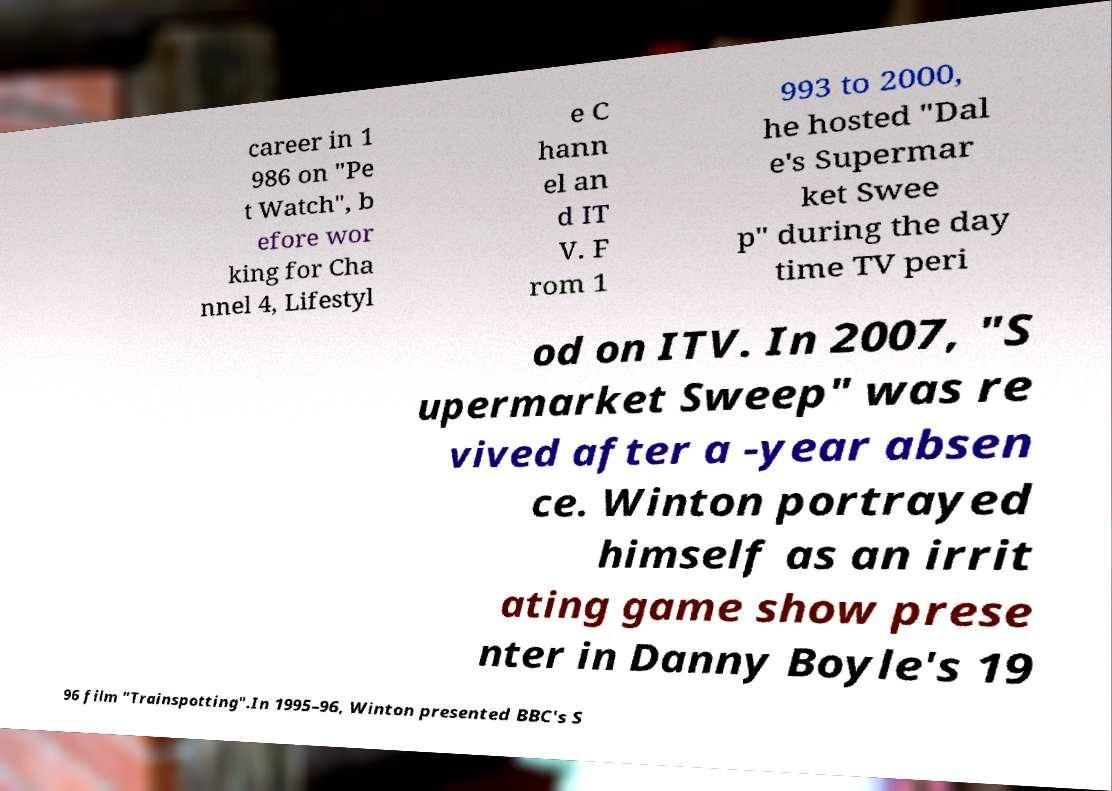Please read and relay the text visible in this image. What does it say? career in 1 986 on "Pe t Watch", b efore wor king for Cha nnel 4, Lifestyl e C hann el an d IT V. F rom 1 993 to 2000, he hosted "Dal e's Supermar ket Swee p" during the day time TV peri od on ITV. In 2007, "S upermarket Sweep" was re vived after a -year absen ce. Winton portrayed himself as an irrit ating game show prese nter in Danny Boyle's 19 96 film "Trainspotting".In 1995–96, Winton presented BBC's S 